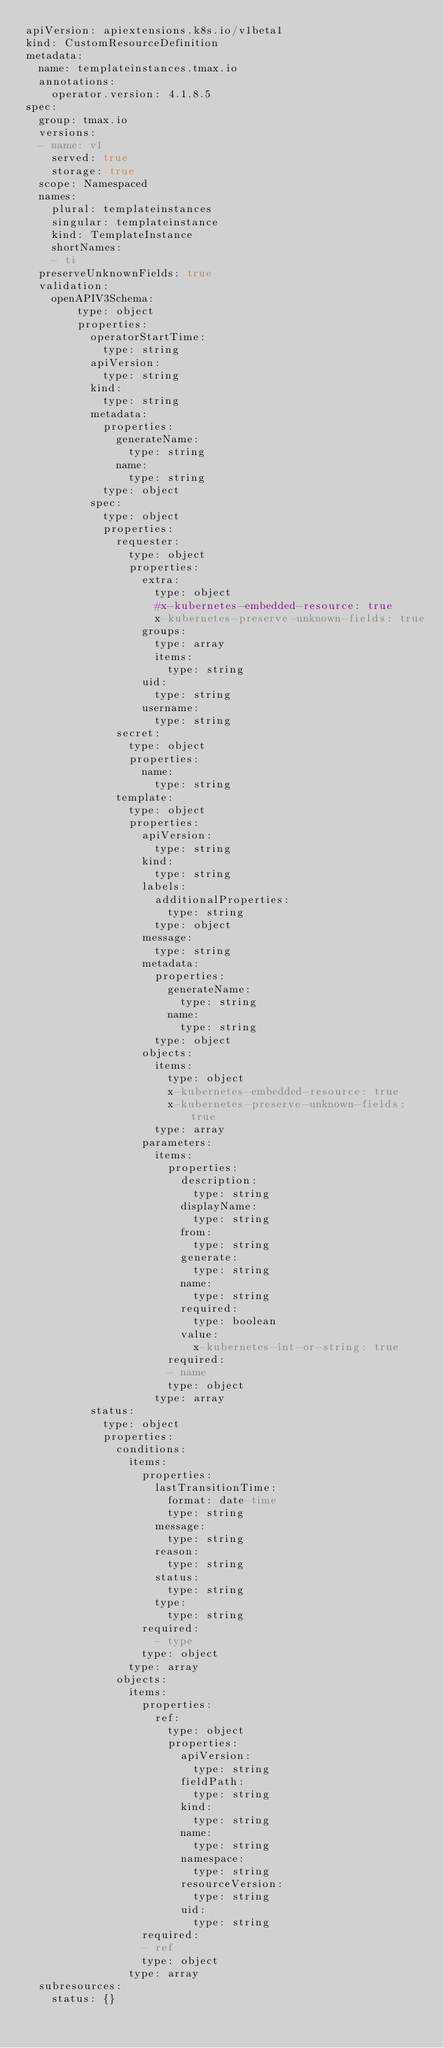Convert code to text. <code><loc_0><loc_0><loc_500><loc_500><_YAML_>apiVersion: apiextensions.k8s.io/v1beta1
kind: CustomResourceDefinition
metadata:
  name: templateinstances.tmax.io
  annotations:
    operator.version: 4.1.8.5
spec:
  group: tmax.io
  versions:
  - name: v1
    served: true
    storage: true
  scope: Namespaced
  names:
    plural: templateinstances
    singular: templateinstance
    kind: TemplateInstance
    shortNames:
    - ti
  preserveUnknownFields: true
  validation:
    openAPIV3Schema:
        type: object
        properties:
          operatorStartTime:
            type: string
          apiVersion:
            type: string
          kind:
            type: string
          metadata:
            properties:
              generateName:
                type: string
              name:
                type: string
            type: object
          spec:
            type: object
            properties:
              requester:
                type: object
                properties:
                  extra:
                    type: object
                    #x-kubernetes-embedded-resource: true
                    x-kubernetes-preserve-unknown-fields: true
                  groups:
                    type: array
                    items:
                      type: string
                  uid:
                    type: string
                  username:
                    type: string
              secret:
                type: object
                properties:
                  name:
                    type: string
              template:
                type: object
                properties:
                  apiVersion:
                    type: string
                  kind:
                    type: string
                  labels:
                    additionalProperties:
                      type: string
                    type: object
                  message:
                    type: string
                  metadata:
                    properties:
                      generateName:
                        type: string
                      name:
                        type: string
                    type: object
                  objects:
                    items:
                      type: object
                      x-kubernetes-embedded-resource: true
                      x-kubernetes-preserve-unknown-fields: true
                    type: array
                  parameters:
                    items:
                      properties:
                        description:
                          type: string
                        displayName:
                          type: string
                        from:
                          type: string
                        generate:
                          type: string
                        name:
                          type: string
                        required:
                          type: boolean
                        value:
                          x-kubernetes-int-or-string: true
                      required:
                      - name
                      type: object
                    type: array
          status:
            type: object
            properties:
              conditions:
                items:
                  properties:
                    lastTransitionTime:
                      format: date-time
                      type: string
                    message:
                      type: string
                    reason:
                      type: string
                    status:
                      type: string
                    type:
                      type: string
                  required:
                    - type
                  type: object
                type: array
              objects:
                items:
                  properties:
                    ref:
                      type: object
                      properties:
                        apiVersion:
                          type: string
                        fieldPath:
                          type: string
                        kind:
                          type: string
                        name:
                          type: string
                        namespace:
                          type: string
                        resourceVersion:
                          type: string
                        uid:
                          type: string
                  required:
                  - ref
                  type: object
                type: array
  subresources:
    status: {}</code> 